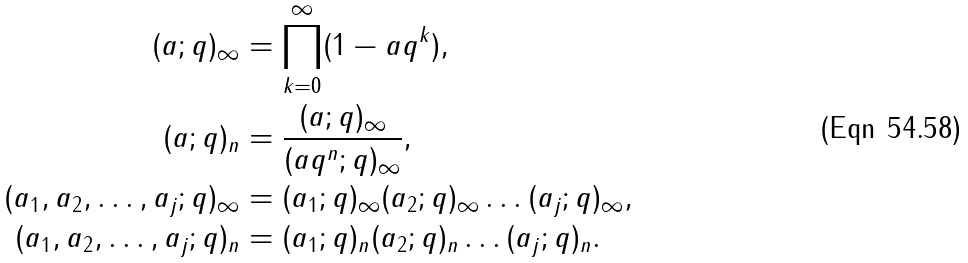<formula> <loc_0><loc_0><loc_500><loc_500>( a ; q ) _ { \infty } & = \prod _ { k = 0 } ^ { \infty } ( 1 - a q ^ { k } ) , \\ ( a ; q ) _ { n } & = \frac { ( a ; q ) _ { \infty } } { ( a q ^ { n } ; q ) _ { \infty } } , \\ ( a _ { 1 } , a _ { 2 } , \dots , a _ { j } ; q ) _ { \infty } & = ( a _ { 1 } ; q ) _ { \infty } ( a _ { 2 } ; q ) _ { \infty } \dots ( a _ { j } ; q ) _ { \infty } , \\ ( a _ { 1 } , a _ { 2 } , \dots , a _ { j } ; q ) _ { n } & = ( a _ { 1 } ; q ) _ { n } ( a _ { 2 } ; q ) _ { n } \dots ( a _ { j } ; q ) _ { n } .</formula> 